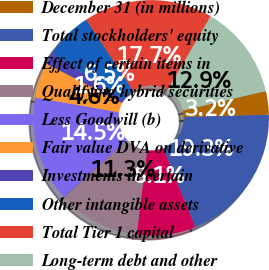Convert chart. <chart><loc_0><loc_0><loc_500><loc_500><pie_chart><fcel>December 31 (in millions)<fcel>Total stockholders' equity<fcel>Effect of certain items in<fcel>Qualifying hybrid securities<fcel>Less Goodwill (b)<fcel>Fair value DVA on derivative<fcel>Investments in certain<fcel>Other intangible assets<fcel>Total Tier 1 capital<fcel>Long-term debt and other<nl><fcel>3.24%<fcel>19.34%<fcel>8.07%<fcel>11.29%<fcel>14.51%<fcel>4.85%<fcel>1.63%<fcel>6.46%<fcel>17.73%<fcel>12.9%<nl></chart> 